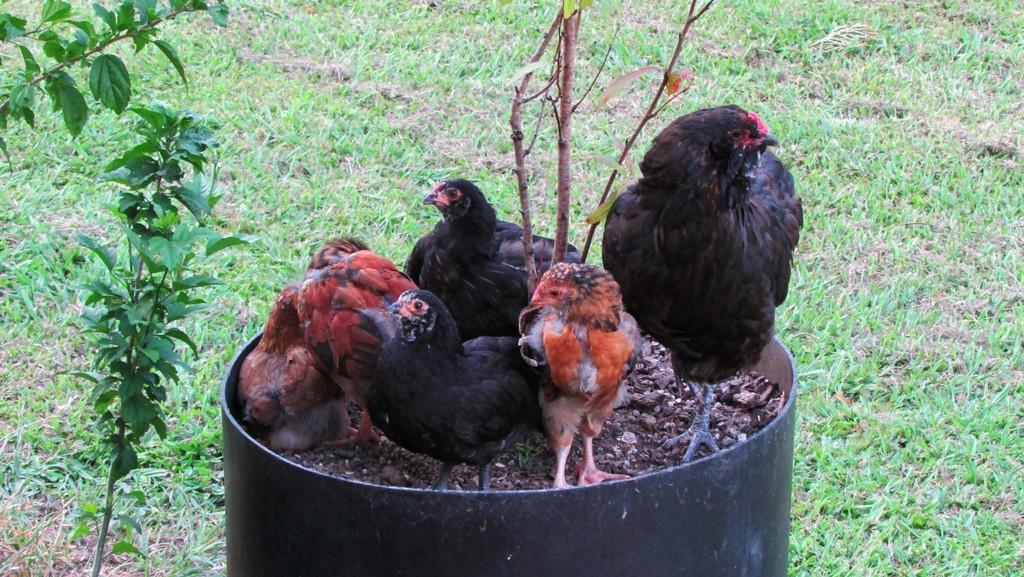What type of animals can be seen in the front of the image? There are hens in the front of the image. What is located on the left side of the image? There is a plant on the left side of the image. What type of vegetation is visible at the bottom of the image? Grass is visible at the bottom of the image. What type of material is present in the middle of the image? There are stones present in the middle of the image. Can you tell me how many pieces of cheese are on the plant in the image? There is no cheese present in the image; it features hens, a plant, grass, and stones. What type of airport is visible in the image? There is no airport present in the image. 